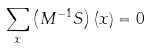<formula> <loc_0><loc_0><loc_500><loc_500>\sum _ { x } \left ( M ^ { - 1 } S \right ) ( x ) = 0</formula> 